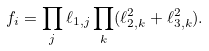<formula> <loc_0><loc_0><loc_500><loc_500>f _ { i } = \prod _ { j } \ell _ { 1 , j } \prod _ { k } ( \ell _ { 2 , k } ^ { 2 } + \ell _ { 3 , k } ^ { 2 } ) .</formula> 